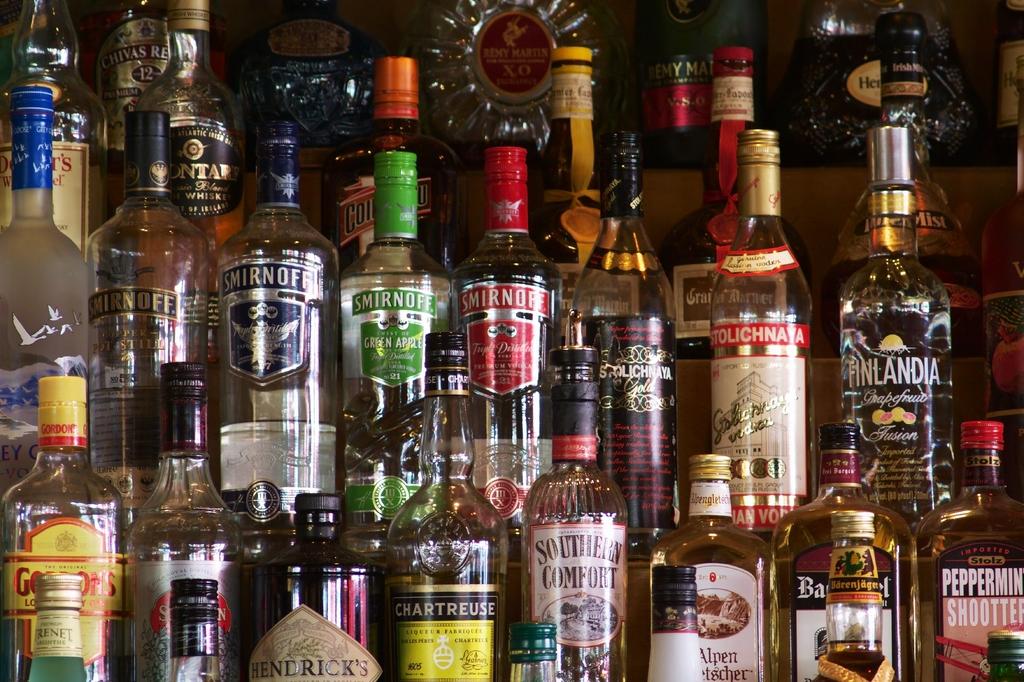Is there a label that says finlandia?
Provide a short and direct response. Yes. Are these all smirnoffs?
Your answer should be very brief. No. 